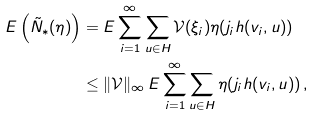Convert formula to latex. <formula><loc_0><loc_0><loc_500><loc_500>E \left ( \tilde { N } _ { \ast } ( \eta ) \right ) & = E \sum _ { i = 1 } ^ { \infty } \sum _ { u \in H } \mathcal { V } ( \xi _ { i } ) \eta ( j _ { i } h ( v _ { i } , u ) ) \\ & \leq \| \mathcal { V } \| _ { \infty } \, E \sum _ { i = 1 } ^ { \infty } \sum _ { u \in H } \eta ( j _ { i } h ( v _ { i } , u ) ) \, ,</formula> 